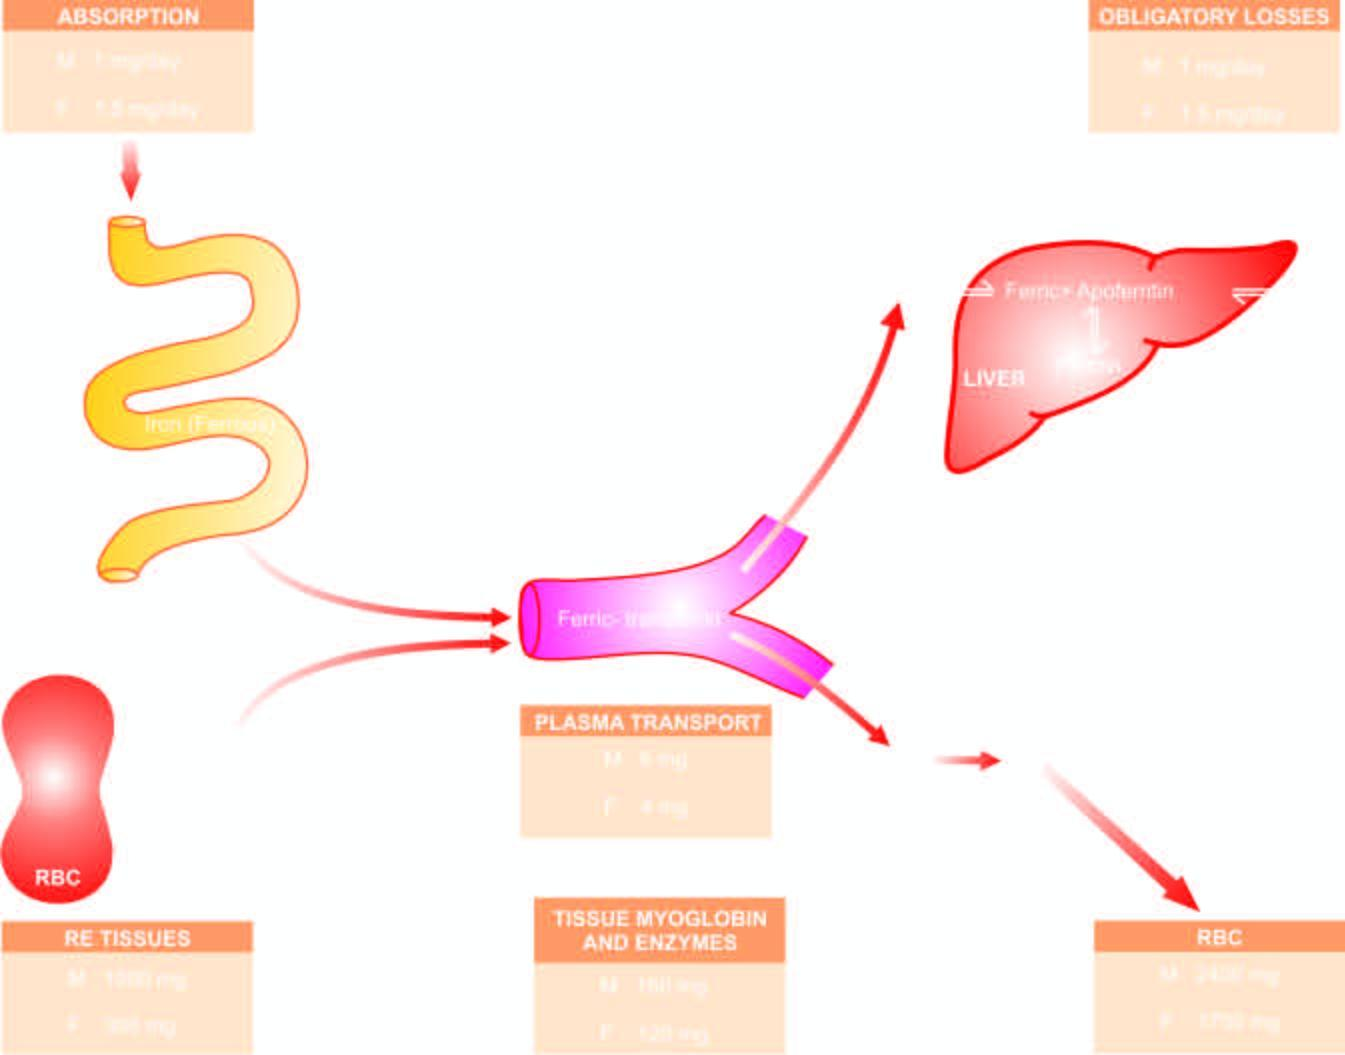what are released into circulation, which on completion of their lifespan of 120 days, die?
Answer the question using a single word or phrase. The mature red cells 